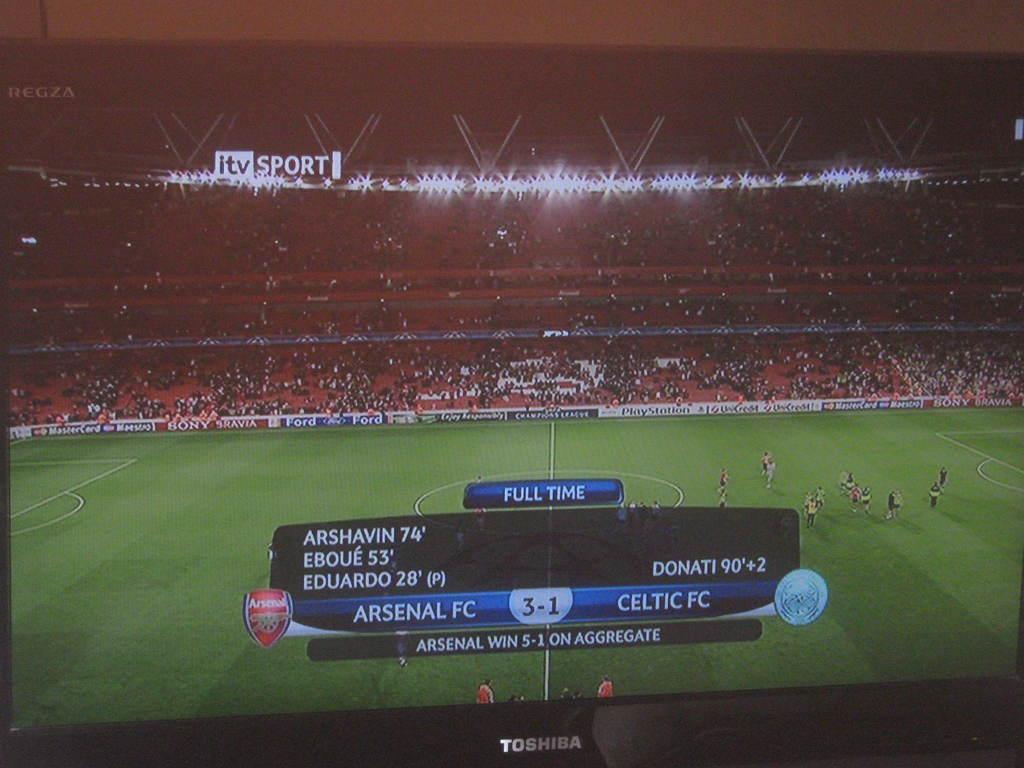How would you summarize this image in a sentence or two? In this image we can see players in a ground. At the bottom there is a text. In the background there are chairs, crowd, lights and sky. 